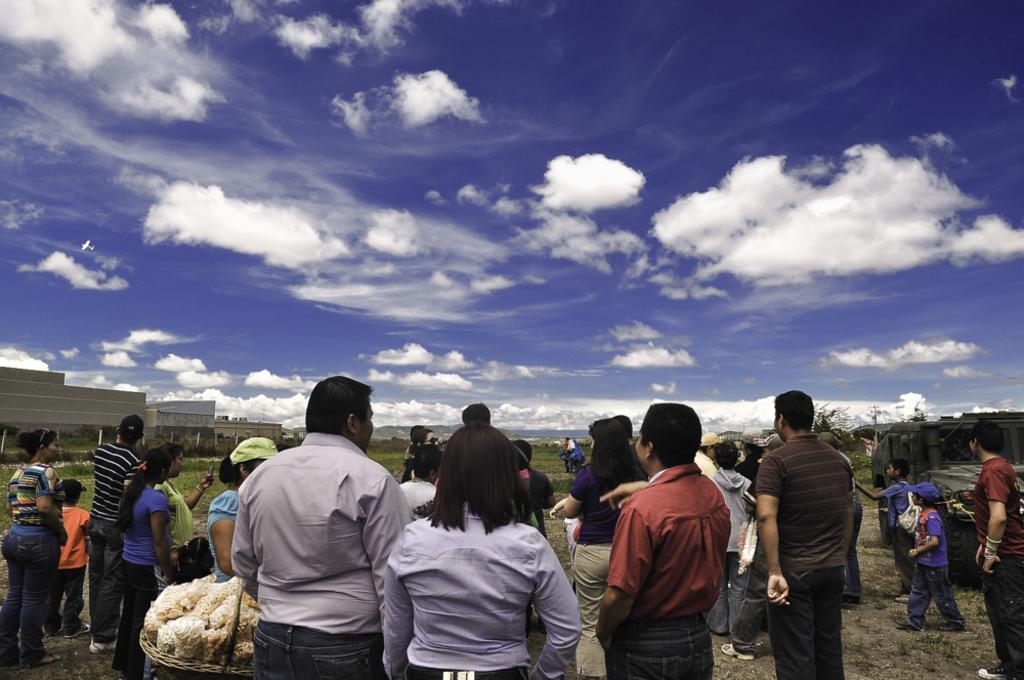Can you describe this image briefly? In this image I can see number of persons are standing on the ground, few buildings, few trees and in the background I can see the sky. 